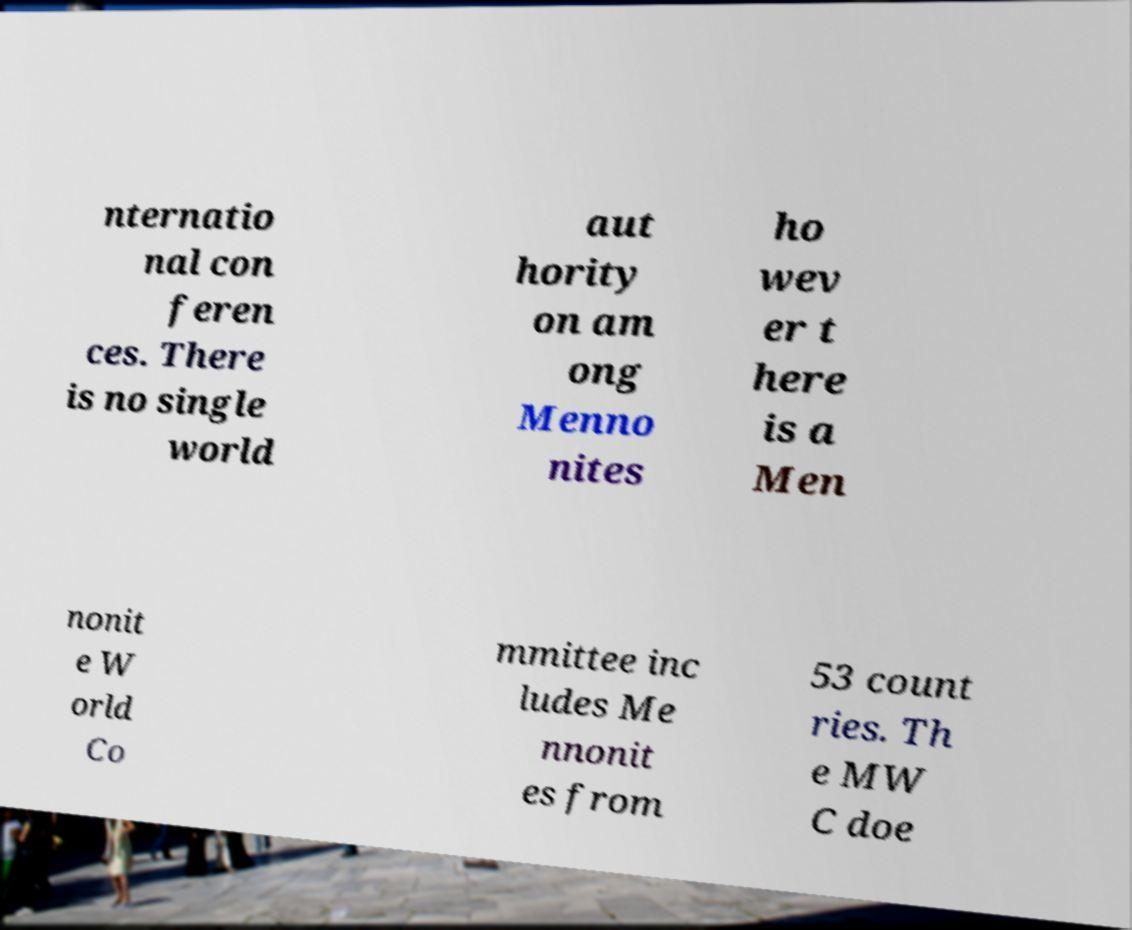Please identify and transcribe the text found in this image. nternatio nal con feren ces. There is no single world aut hority on am ong Menno nites ho wev er t here is a Men nonit e W orld Co mmittee inc ludes Me nnonit es from 53 count ries. Th e MW C doe 